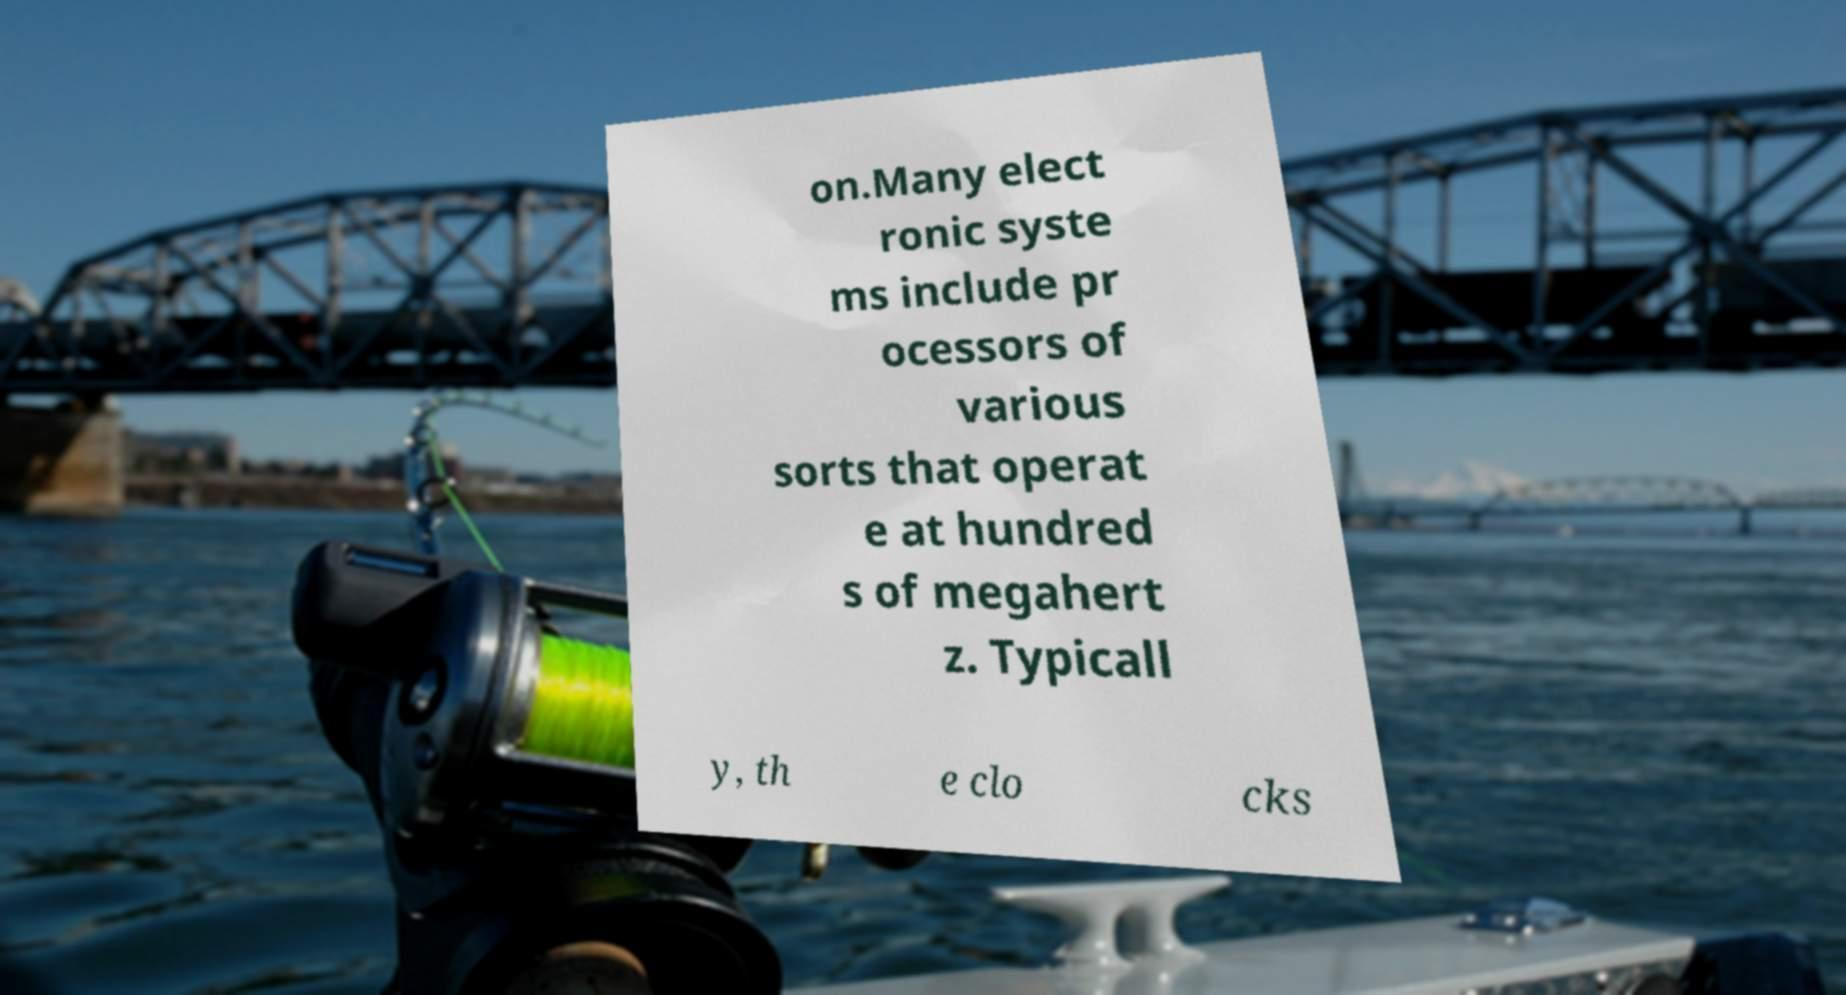Can you accurately transcribe the text from the provided image for me? on.Many elect ronic syste ms include pr ocessors of various sorts that operat e at hundred s of megahert z. Typicall y, th e clo cks 